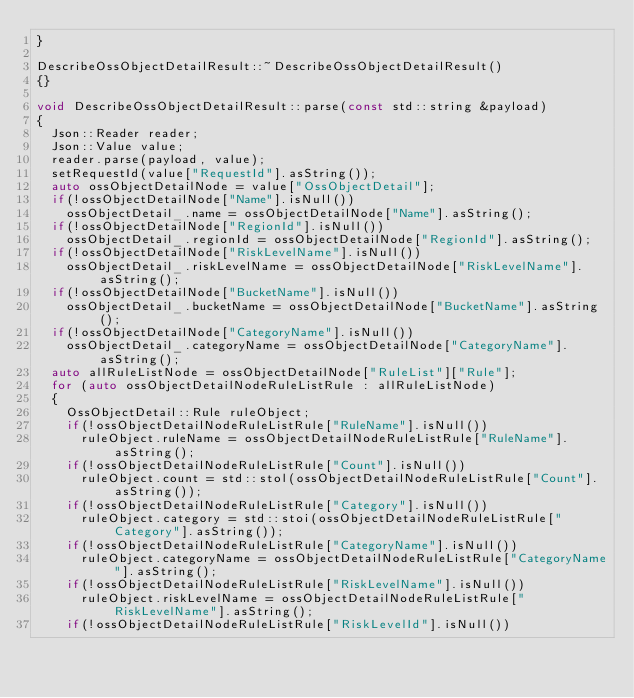<code> <loc_0><loc_0><loc_500><loc_500><_C++_>}

DescribeOssObjectDetailResult::~DescribeOssObjectDetailResult()
{}

void DescribeOssObjectDetailResult::parse(const std::string &payload)
{
	Json::Reader reader;
	Json::Value value;
	reader.parse(payload, value);
	setRequestId(value["RequestId"].asString());
	auto ossObjectDetailNode = value["OssObjectDetail"];
	if(!ossObjectDetailNode["Name"].isNull())
		ossObjectDetail_.name = ossObjectDetailNode["Name"].asString();
	if(!ossObjectDetailNode["RegionId"].isNull())
		ossObjectDetail_.regionId = ossObjectDetailNode["RegionId"].asString();
	if(!ossObjectDetailNode["RiskLevelName"].isNull())
		ossObjectDetail_.riskLevelName = ossObjectDetailNode["RiskLevelName"].asString();
	if(!ossObjectDetailNode["BucketName"].isNull())
		ossObjectDetail_.bucketName = ossObjectDetailNode["BucketName"].asString();
	if(!ossObjectDetailNode["CategoryName"].isNull())
		ossObjectDetail_.categoryName = ossObjectDetailNode["CategoryName"].asString();
	auto allRuleListNode = ossObjectDetailNode["RuleList"]["Rule"];
	for (auto ossObjectDetailNodeRuleListRule : allRuleListNode)
	{
		OssObjectDetail::Rule ruleObject;
		if(!ossObjectDetailNodeRuleListRule["RuleName"].isNull())
			ruleObject.ruleName = ossObjectDetailNodeRuleListRule["RuleName"].asString();
		if(!ossObjectDetailNodeRuleListRule["Count"].isNull())
			ruleObject.count = std::stol(ossObjectDetailNodeRuleListRule["Count"].asString());
		if(!ossObjectDetailNodeRuleListRule["Category"].isNull())
			ruleObject.category = std::stoi(ossObjectDetailNodeRuleListRule["Category"].asString());
		if(!ossObjectDetailNodeRuleListRule["CategoryName"].isNull())
			ruleObject.categoryName = ossObjectDetailNodeRuleListRule["CategoryName"].asString();
		if(!ossObjectDetailNodeRuleListRule["RiskLevelName"].isNull())
			ruleObject.riskLevelName = ossObjectDetailNodeRuleListRule["RiskLevelName"].asString();
		if(!ossObjectDetailNodeRuleListRule["RiskLevelId"].isNull())</code> 